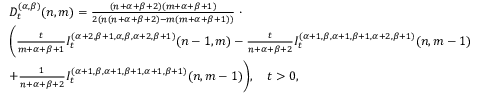Convert formula to latex. <formula><loc_0><loc_0><loc_500><loc_500>\begin{array} { r l } & { D _ { t } ^ { ( \alpha , \beta ) } ( n , m ) = \frac { ( n + \alpha + \beta + 2 ) ( m + \alpha + \beta + 1 ) } { 2 ( n ( n + \alpha + \beta + 2 ) - m ( m + \alpha + \beta + 1 ) ) } \, \cdot } \\ & { \left ( \frac { t } { m + \alpha + \beta + 1 } I _ { t } ^ { ( \alpha + 2 , \beta + 1 , \alpha , \beta , \alpha + 2 , \beta + 1 ) } { ( n - 1 , m ) } - \frac { t } { n + \alpha + \beta + 2 } I _ { t } ^ { ( \alpha + 1 , \beta , \alpha + 1 , \beta + 1 , \alpha + 2 , \beta + 1 ) } { ( n , m - 1 ) } } \\ & { + \frac { 1 } { n + \alpha + \beta + 2 } I _ { t } ^ { ( \alpha + 1 , \beta , \alpha + 1 , \beta + 1 , \alpha + 1 , \beta + 1 ) } { ( n , m - 1 ) } \right ) , \quad t > 0 , } \end{array}</formula> 